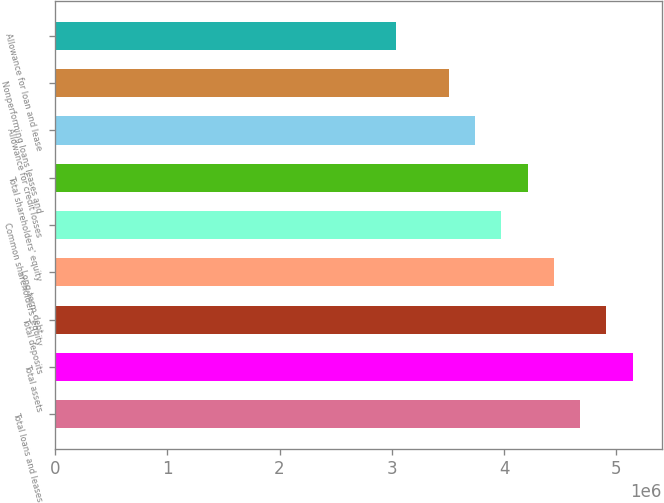Convert chart. <chart><loc_0><loc_0><loc_500><loc_500><bar_chart><fcel>Total loans and leases<fcel>Total assets<fcel>Total deposits<fcel>Long-term debt<fcel>Common shareholders' equity<fcel>Total shareholders' equity<fcel>Allowance for credit losses<fcel>Nonperforming loans leases and<fcel>Allowance for loan and lease<nl><fcel>4.67707e+06<fcel>5.14478e+06<fcel>4.91093e+06<fcel>4.44322e+06<fcel>3.97551e+06<fcel>4.20937e+06<fcel>3.74166e+06<fcel>3.50781e+06<fcel>3.0401e+06<nl></chart> 